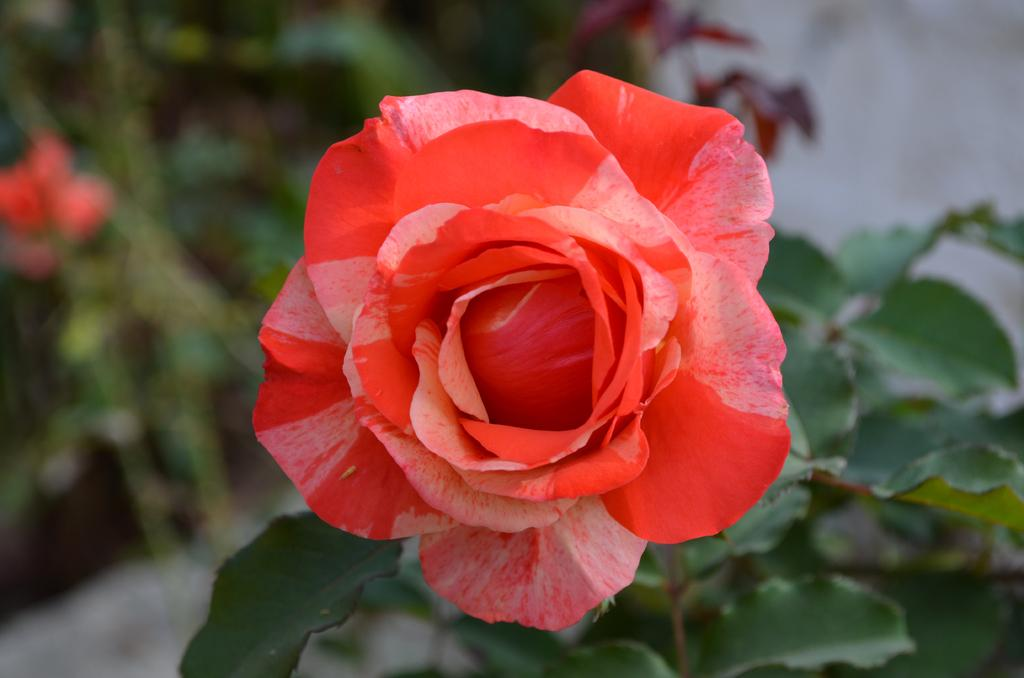What is the main subject in the foreground of the image? There is a rose flower in the foreground of the image. What can be seen in the background of the image? There are plants in the background of the image. How is the background of the image depicted? The background of the image is blurred. What type of bomb is depicted in the image? There is no bomb present in the image; it features a rose flower in the foreground and plants in the background. What type of canvas is used for the image? The image is not a painting or on a canvas; it is a photograph. 